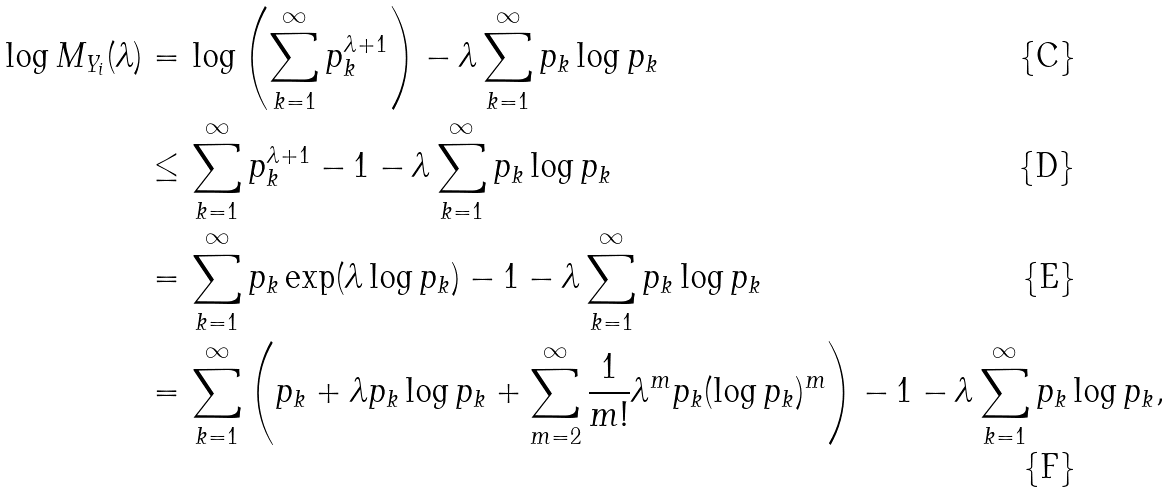<formula> <loc_0><loc_0><loc_500><loc_500>\log M _ { Y _ { i } } ( \lambda ) = & \, \log \left ( \sum _ { k = 1 } ^ { \infty } p _ { k } ^ { \lambda + 1 } \right ) - \lambda \sum _ { k = 1 } ^ { \infty } p _ { k } \log p _ { k } \\ \leq & \, \sum _ { k = 1 } ^ { \infty } p _ { k } ^ { \lambda + 1 } - 1 - \lambda \sum _ { k = 1 } ^ { \infty } p _ { k } \log p _ { k } \\ = & \, \sum _ { k = 1 } ^ { \infty } p _ { k } \exp ( \lambda \log p _ { k } ) - 1 - \lambda \sum _ { k = 1 } ^ { \infty } p _ { k } \log p _ { k } \\ = & \, \sum _ { k = 1 } ^ { \infty } \left ( p _ { k } + \lambda p _ { k } \log p _ { k } + \sum _ { m = 2 } ^ { \infty } \frac { 1 } { m ! } \lambda ^ { m } p _ { k } ( \log p _ { k } ) ^ { m } \right ) - 1 - \lambda \sum _ { k = 1 } ^ { \infty } p _ { k } \log p _ { k } ,</formula> 